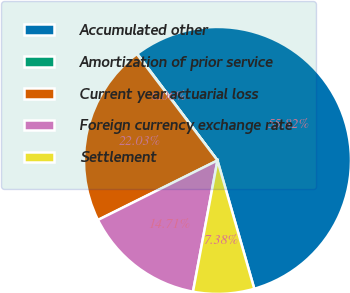Convert chart. <chart><loc_0><loc_0><loc_500><loc_500><pie_chart><fcel>Accumulated other<fcel>Amortization of prior service<fcel>Current year actuarial loss<fcel>Foreign currency exchange rate<fcel>Settlement<nl><fcel>55.82%<fcel>0.06%<fcel>22.03%<fcel>14.71%<fcel>7.38%<nl></chart> 